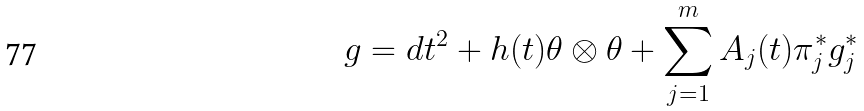Convert formula to latex. <formula><loc_0><loc_0><loc_500><loc_500>g = d t ^ { 2 } + h ( t ) \theta \otimes \theta + \sum _ { j = 1 } ^ { m } A _ { j } ( t ) \pi _ { j } ^ { \ast } g ^ { \ast } _ { j }</formula> 